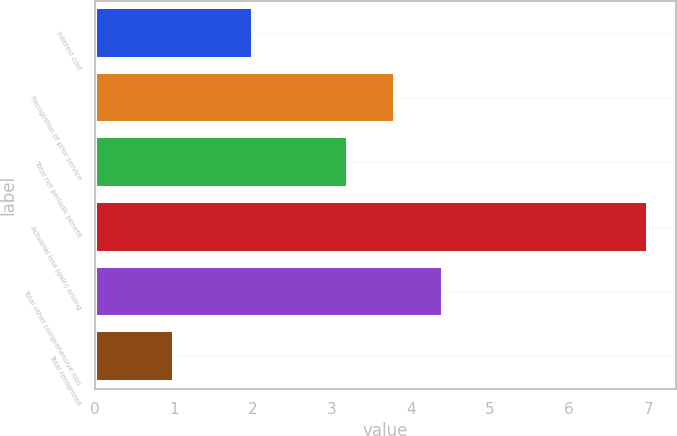<chart> <loc_0><loc_0><loc_500><loc_500><bar_chart><fcel>Interest cost<fcel>Recognition of prior service<fcel>Total net periodic benefit<fcel>Actuarial loss (gain) arising<fcel>Total other comprehensive loss<fcel>Total recognized<nl><fcel>2<fcel>3.8<fcel>3.2<fcel>7<fcel>4.4<fcel>1<nl></chart> 